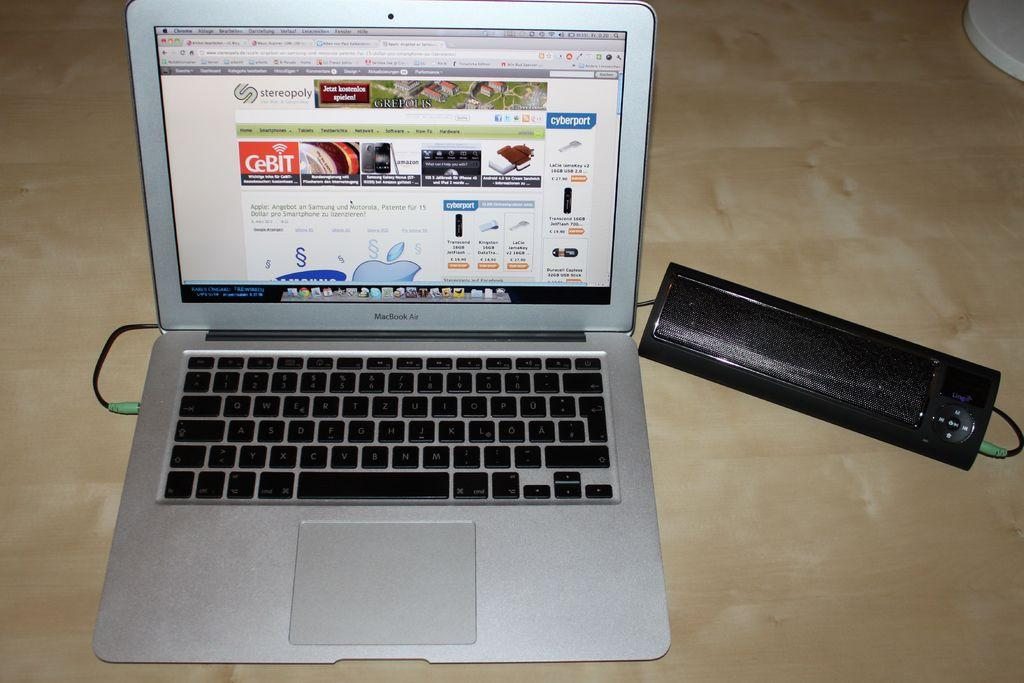<image>
Render a clear and concise summary of the photo. A laptop is open and a web page is showing which contains German text concerning mobile phones. 